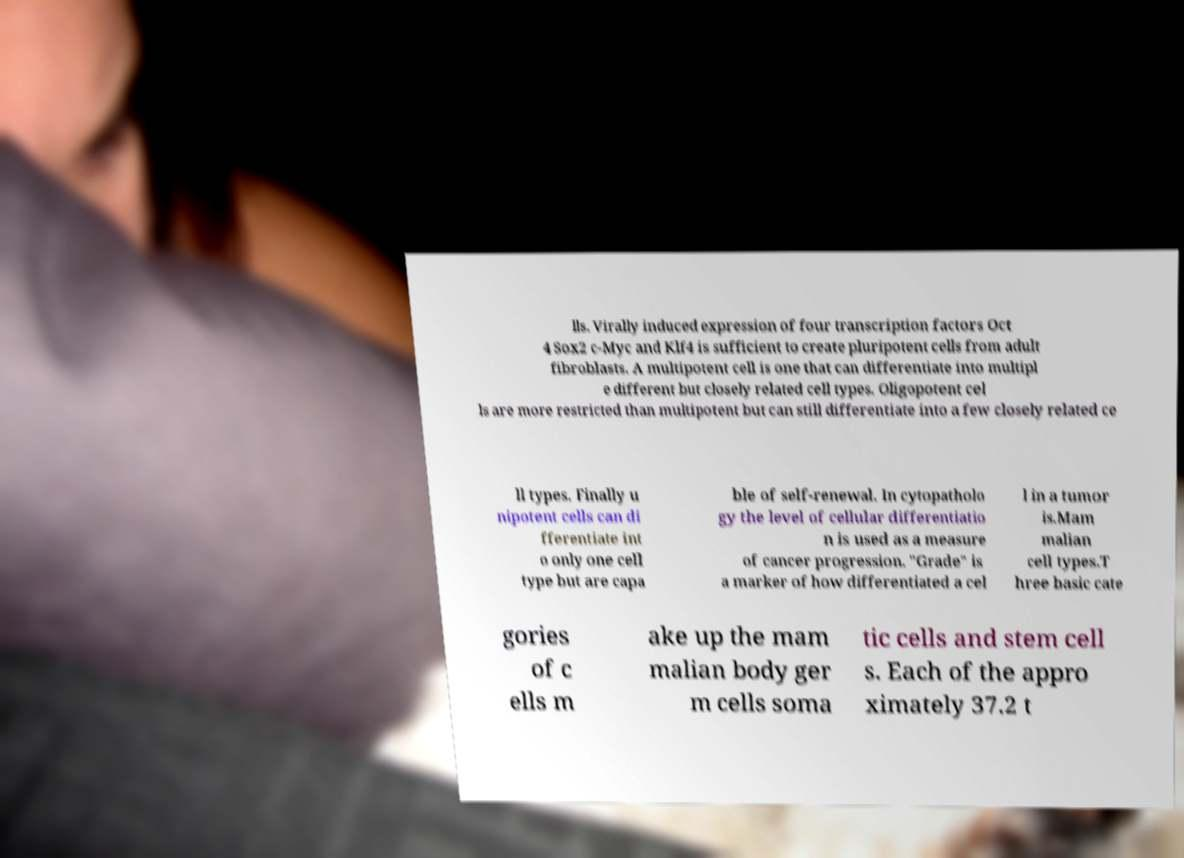What messages or text are displayed in this image? I need them in a readable, typed format. lls. Virally induced expression of four transcription factors Oct 4 Sox2 c-Myc and Klf4 is sufficient to create pluripotent cells from adult fibroblasts. A multipotent cell is one that can differentiate into multipl e different but closely related cell types. Oligopotent cel ls are more restricted than multipotent but can still differentiate into a few closely related ce ll types. Finally u nipotent cells can di fferentiate int o only one cell type but are capa ble of self-renewal. In cytopatholo gy the level of cellular differentiatio n is used as a measure of cancer progression. "Grade" is a marker of how differentiated a cel l in a tumor is.Mam malian cell types.T hree basic cate gories of c ells m ake up the mam malian body ger m cells soma tic cells and stem cell s. Each of the appro ximately 37.2 t 